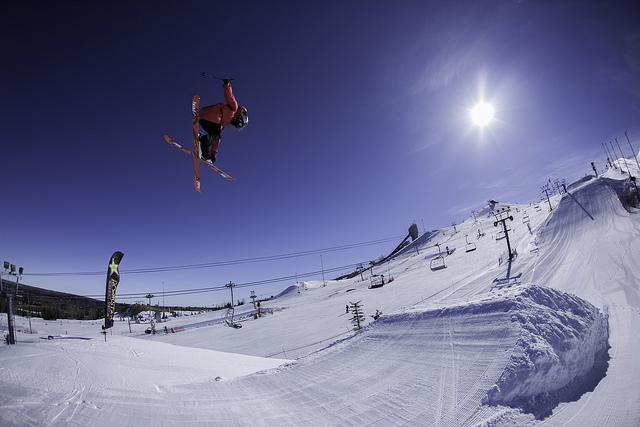Has the hill been groomed?
Answer briefly. Yes. Where is the sun?
Give a very brief answer. Sky. Is the man on air?
Write a very short answer. Yes. What is this person doing?
Write a very short answer. Skiing. Why is the man in mid-air?
Concise answer only. Skiing. What is the man doing?
Keep it brief. Skiing. Is the sun shining clearly?
Quick response, please. Yes. How does the man get up the hill?
Be succinct. Ski lift. 